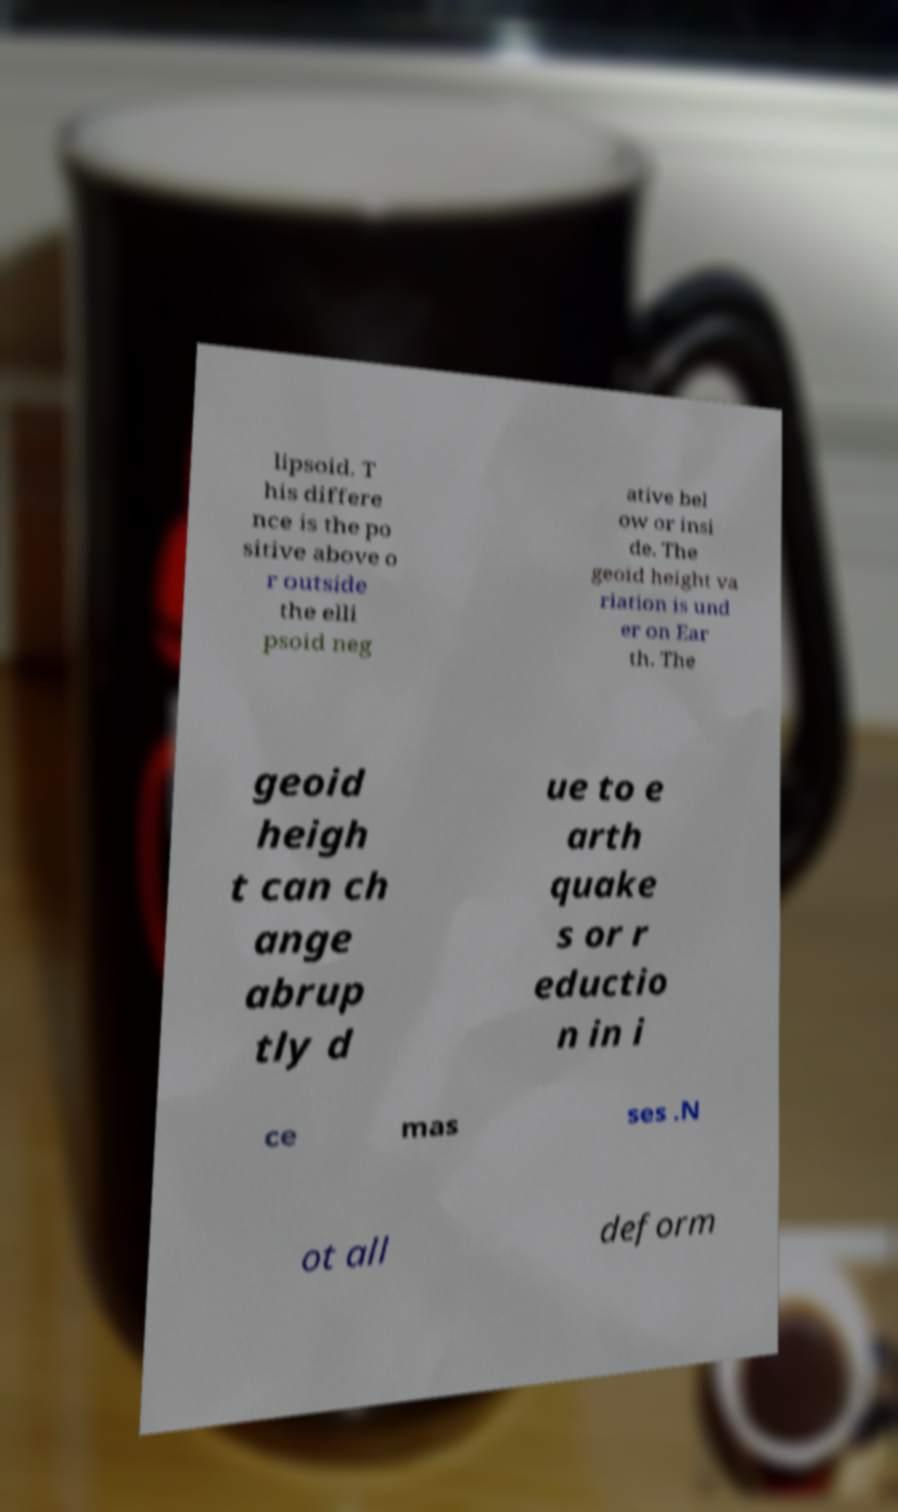There's text embedded in this image that I need extracted. Can you transcribe it verbatim? lipsoid. T his differe nce is the po sitive above o r outside the elli psoid neg ative bel ow or insi de. The geoid height va riation is und er on Ear th. The geoid heigh t can ch ange abrup tly d ue to e arth quake s or r eductio n in i ce mas ses .N ot all deform 